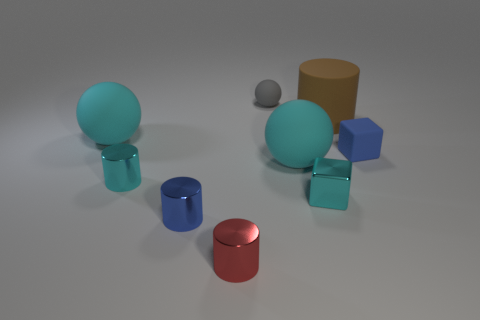How many cyan balls must be subtracted to get 1 cyan balls? 1 Add 1 tiny things. How many objects exist? 10 Subtract all small gray matte balls. How many balls are left? 2 Subtract 1 cyan blocks. How many objects are left? 8 Subtract all blocks. How many objects are left? 7 Subtract 2 blocks. How many blocks are left? 0 Subtract all green spheres. Subtract all yellow cylinders. How many spheres are left? 3 Subtract all yellow spheres. How many red blocks are left? 0 Subtract all brown balls. Subtract all metal cylinders. How many objects are left? 6 Add 8 small matte balls. How many small matte balls are left? 9 